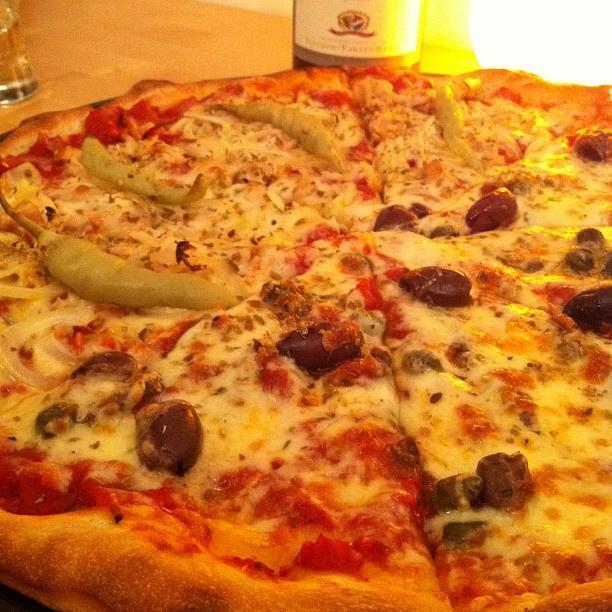How many purple ties are there?
Give a very brief answer. 0. 